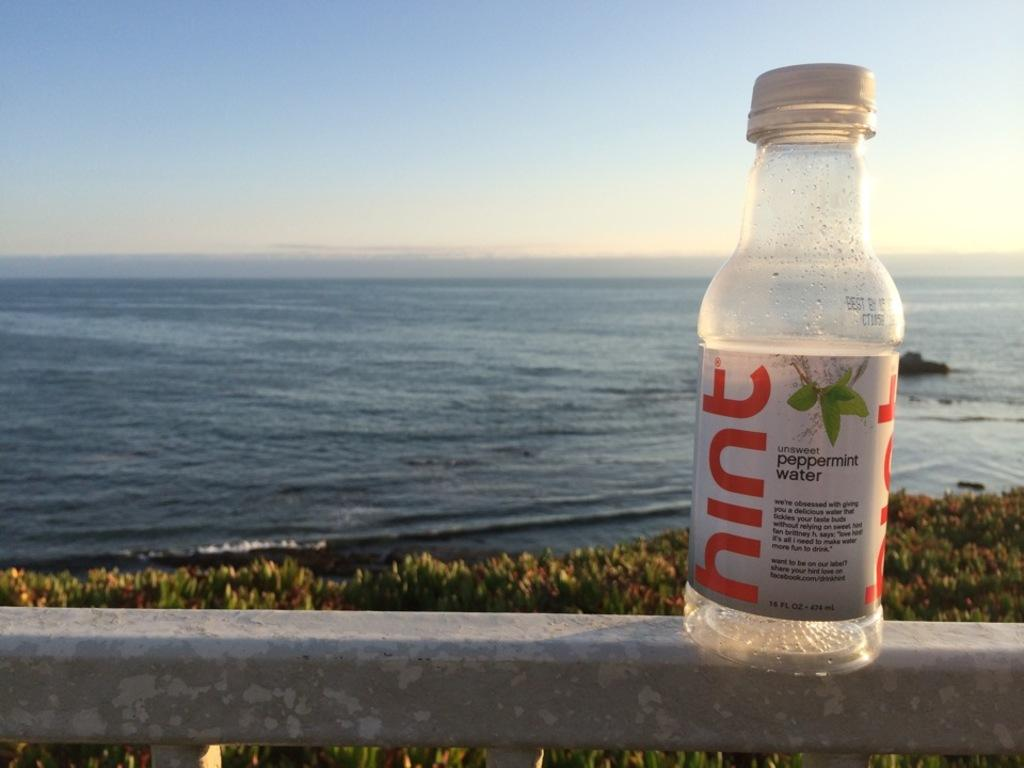<image>
Relay a brief, clear account of the picture shown. A BOTTLE OF HINT IS SITTING ON A RAIL WITH THE OCEAN IN FRONT OF IT. 